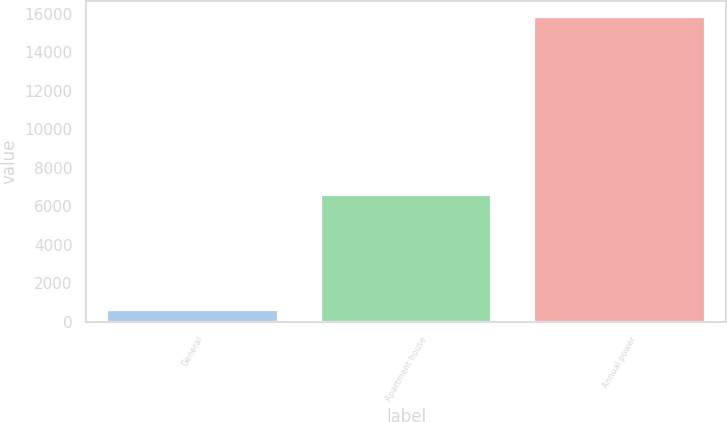Convert chart to OTSL. <chart><loc_0><loc_0><loc_500><loc_500><bar_chart><fcel>General<fcel>Apartment house<fcel>Annual power<nl><fcel>594<fcel>6574<fcel>15848<nl></chart> 